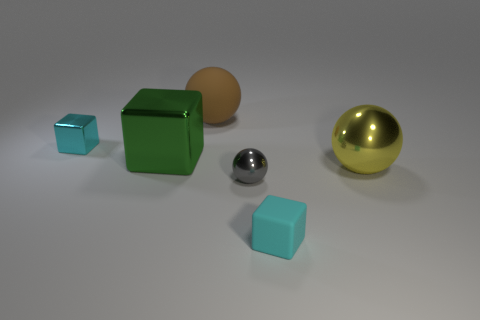Add 1 blue metallic blocks. How many objects exist? 7 Subtract 0 red balls. How many objects are left? 6 Subtract all large green things. Subtract all large yellow shiny cylinders. How many objects are left? 5 Add 2 big green cubes. How many big green cubes are left? 3 Add 5 big rubber balls. How many big rubber balls exist? 6 